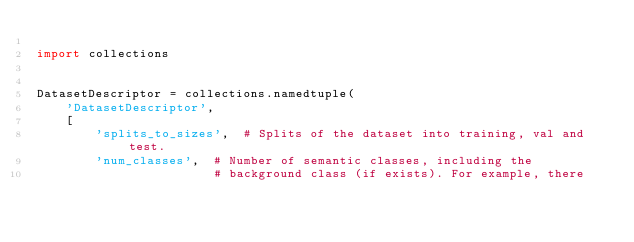<code> <loc_0><loc_0><loc_500><loc_500><_Python_>
import collections


DatasetDescriptor = collections.namedtuple(
    'DatasetDescriptor',
    [
        'splits_to_sizes',  # Splits of the dataset into training, val and test.
        'num_classes',  # Number of semantic classes, including the
                        # background class (if exists). For example, there</code> 